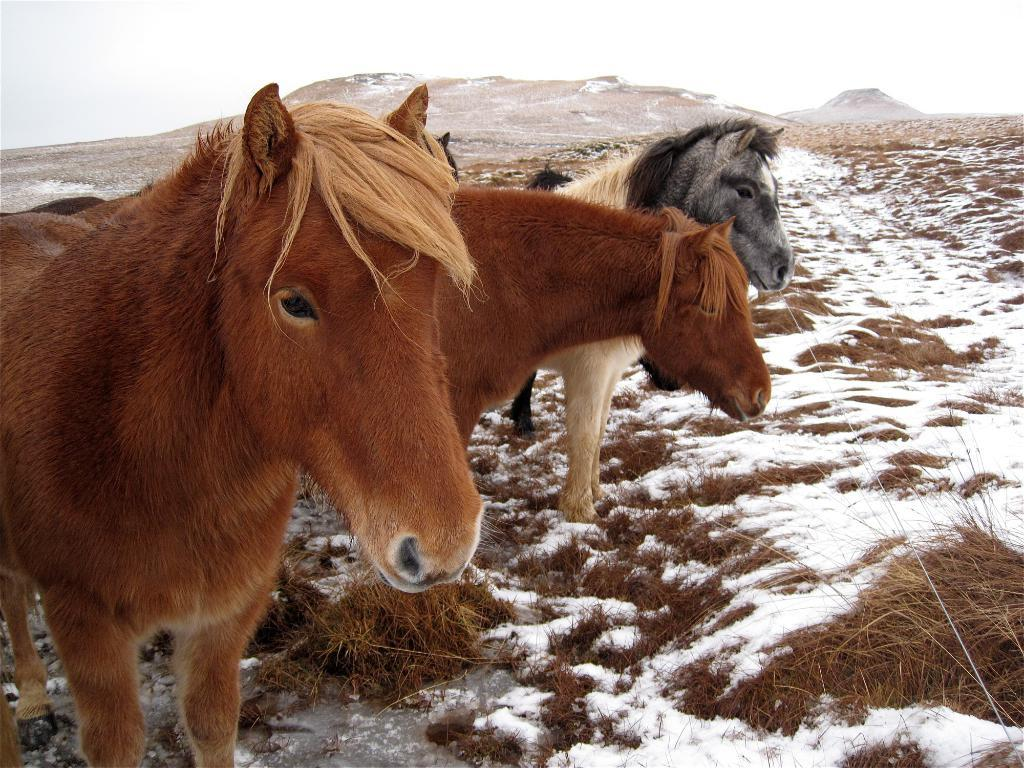How many ponies are in the image? There are three ponies in the image. What is the position of the ponies in the image? The ponies are standing on the floor. What can be seen in the background of the image? There are hills in the background of the image. What is the weather like in the image? The presence of snow suggests that it is cold or wintry. What type of vegetation is visible in the image? There is dry grass in the image. Can you tell me how many cats are sitting on the wrench in the image? There are no cats or wrenches present in the image; it features three ponies standing on the floor with snow and hills in the background. 